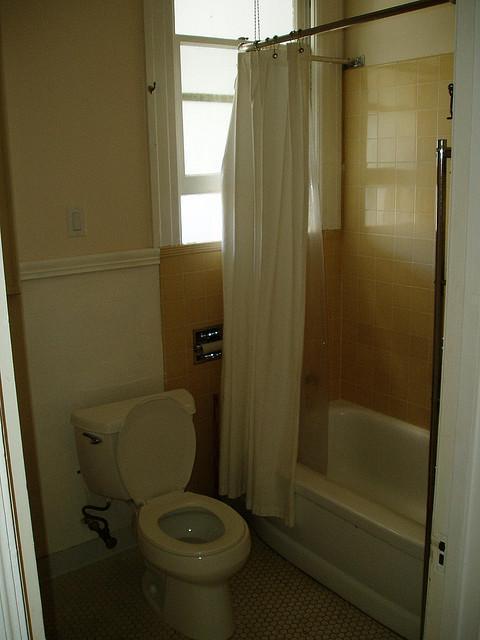How many men are wearing a safety vest?
Give a very brief answer. 0. 